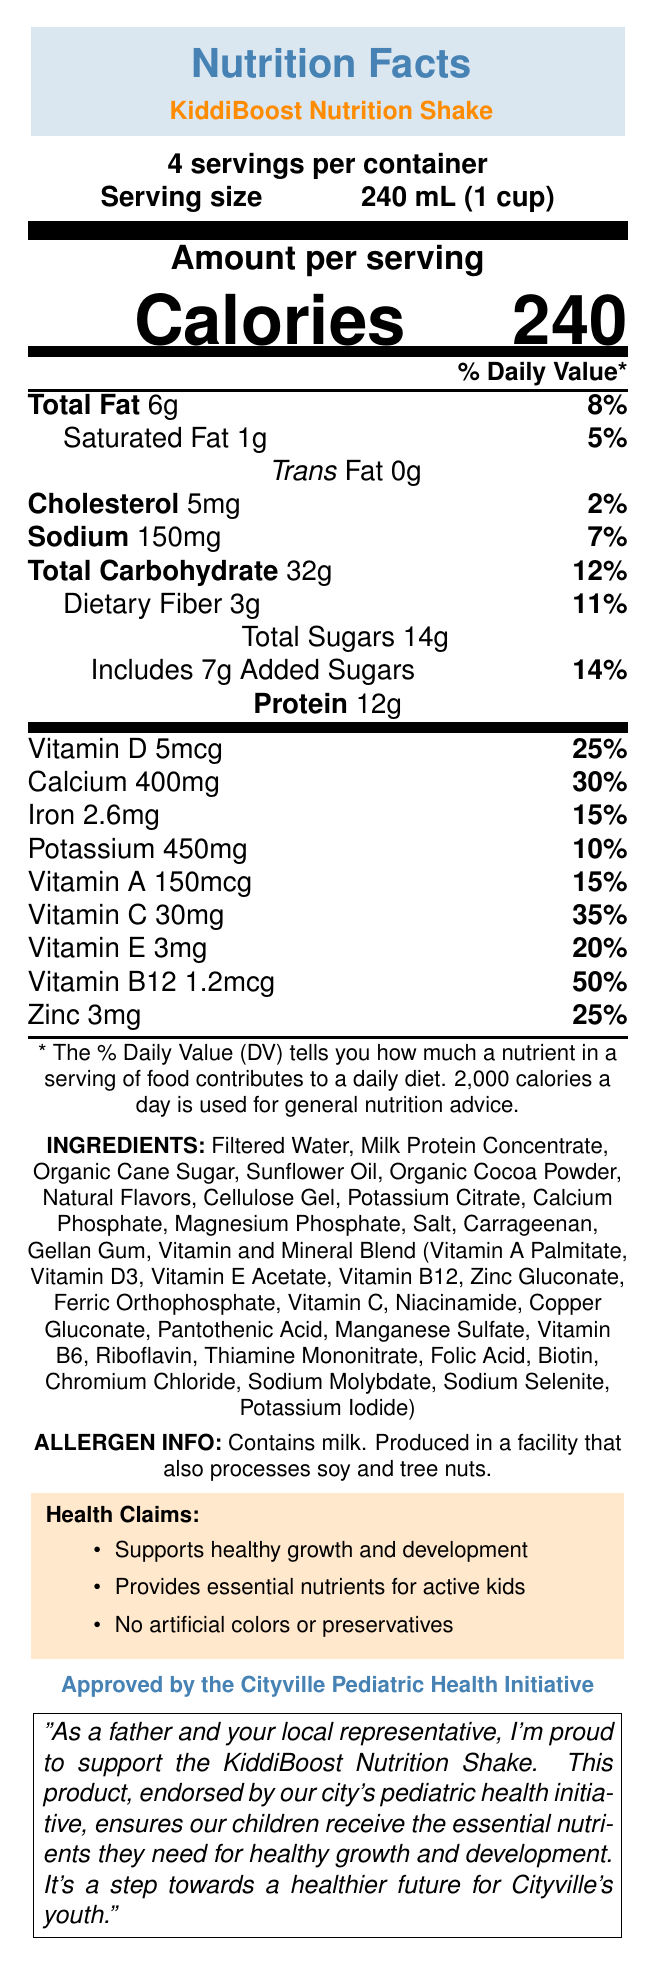what is the serving size for KiddiBoost Nutrition Shake? The document specifies the serving size as 240 mL (1 cup).
Answer: 240 mL (1 cup) how many calories are in a single serving of KiddiBoost Nutrition Shake? The document states that there are 240 calories per serving.
Answer: 240 how much protein does a serving provide? According to the document, a serving provides 12g of protein.
Answer: 12g how many servings are in a container of KiddiBoost Nutrition Shake? The document mentions that there are 4 servings per container.
Answer: 4 what percentage of the daily value is the dietary fiber in one serving? The document lists the daily value percentage for dietary fiber as 11%.
Answer: 11% how much added sugar is there per serving? The document indicates that each serving includes 7g of added sugars.
Answer: 7g which of the following vitamins has the highest percentage of daily value per serving? A. Vitamin A B. Vitamin C C. Vitamin D D. Vitamin B12 The document shows that Vitamin B12 has a daily value of 50%, which is the highest among the listed vitamins.
Answer: D. Vitamin B12 how much potassium does one serving contain? A. 450mg B. 400mg C. 150mg D. 30mg The document indicates that one serving contains 450mg of potassium.
Answer: A. 450mg does the product contain any allergens? The document states that the product contains milk and is produced in a facility that also processes soy and tree nuts.
Answer: Yes is the KiddiBoost Nutrition Shake endorsed by any organization? The document mentions that the product is endorsed by the Cityville Pediatric Health Initiative.
Answer: Yes summarize the main idea of this document. The document primarily describes the nutrition facts, ingredients, allergen information, health claims, and an endorsement by the Cityville Pediatric Health Initiative, highlighting the product's benefits for children's health.
Answer: The KiddiBoost Nutrition Shake is a children's meal replacement drink endorsed by the Cityville Pediatric Health Initiative, providing essential nutrients for healthy growth and development with no artificial colors or preservatives. what are the main ingredients in the KiddiBoost Nutrition Shake? The document lists these as some of the first ingredients, indicating they are the main components of the product.
Answer: Filtered Water, Milk Protein Concentrate, Organic Cane Sugar, Sunflower Oil, Organic Cocoa Powder is there any information about where the KiddiBoost Nutrition Shake is manufactured? The document does not provide any details about the manufacturing location of the KiddiBoost Nutrition Shake.
Answer: Not enough information how much Vitamin D does a serving of KiddiBoost Nutrition Shake provide? The document indicates that a serving contains 5mcg of Vitamin D, which is 25% of the daily value.
Answer: 5mcg what health claim is made about the KiddiBoost Nutrition Shake? The document lists "Supports healthy growth and development" as one of the health claims.
Answer: Supports healthy growth and development explain the politician's stance on KiddiBoost Nutrition Shake. The document includes a statement from the local politician expressing pride and support for the product, emphasizing its benefits for children's health and the endorsement by the city's pediatric health initiative.
Answer: The politician supports the KiddiBoost Nutrition Shake, emphasizing that it ensures children receive essential nutrients for healthy growth and development, aligning with their role as a father and local representative. 